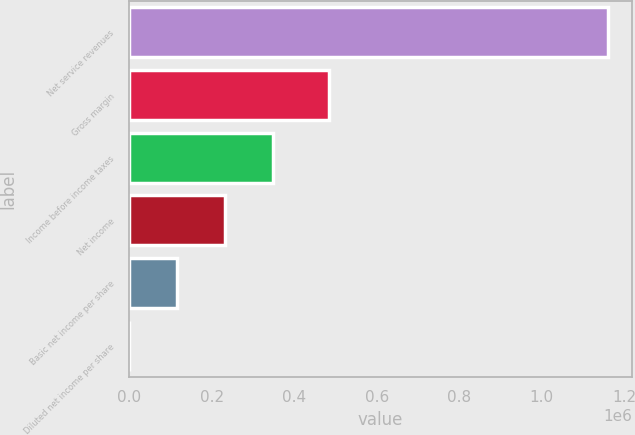Convert chart. <chart><loc_0><loc_0><loc_500><loc_500><bar_chart><fcel>Net service revenues<fcel>Gross margin<fcel>Income before income taxes<fcel>Net income<fcel>Basic net income per share<fcel>Diluted net income per share<nl><fcel>1.16009e+06<fcel>483573<fcel>348026<fcel>232018<fcel>116009<fcel>0.43<nl></chart> 